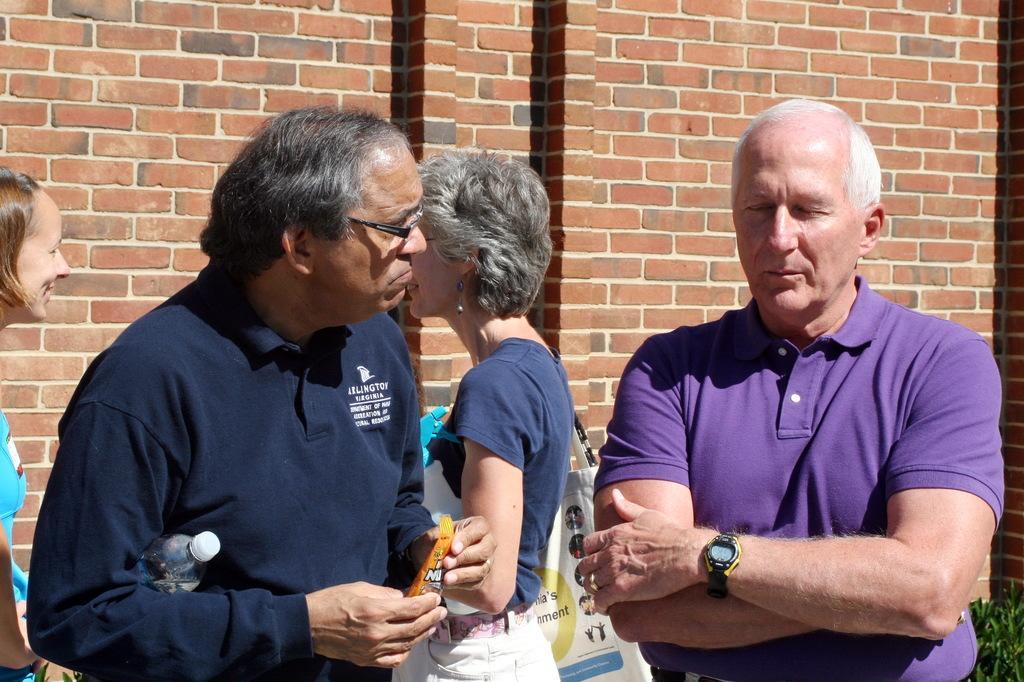Please provide a concise description of this image. In this picture there are people standing, among them there is a woman holding a bottle and carrying a bag. In the background of the image we can see wall and leaves. 